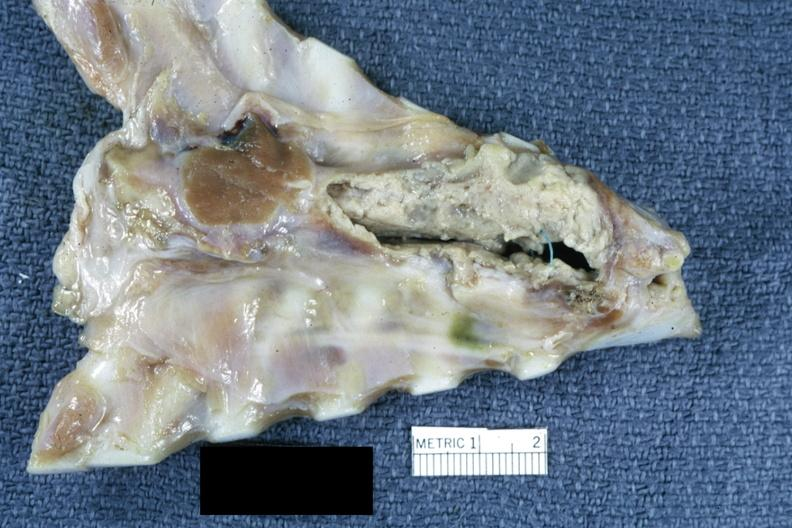what is present?
Answer the question using a single word or phrase. Thorax 